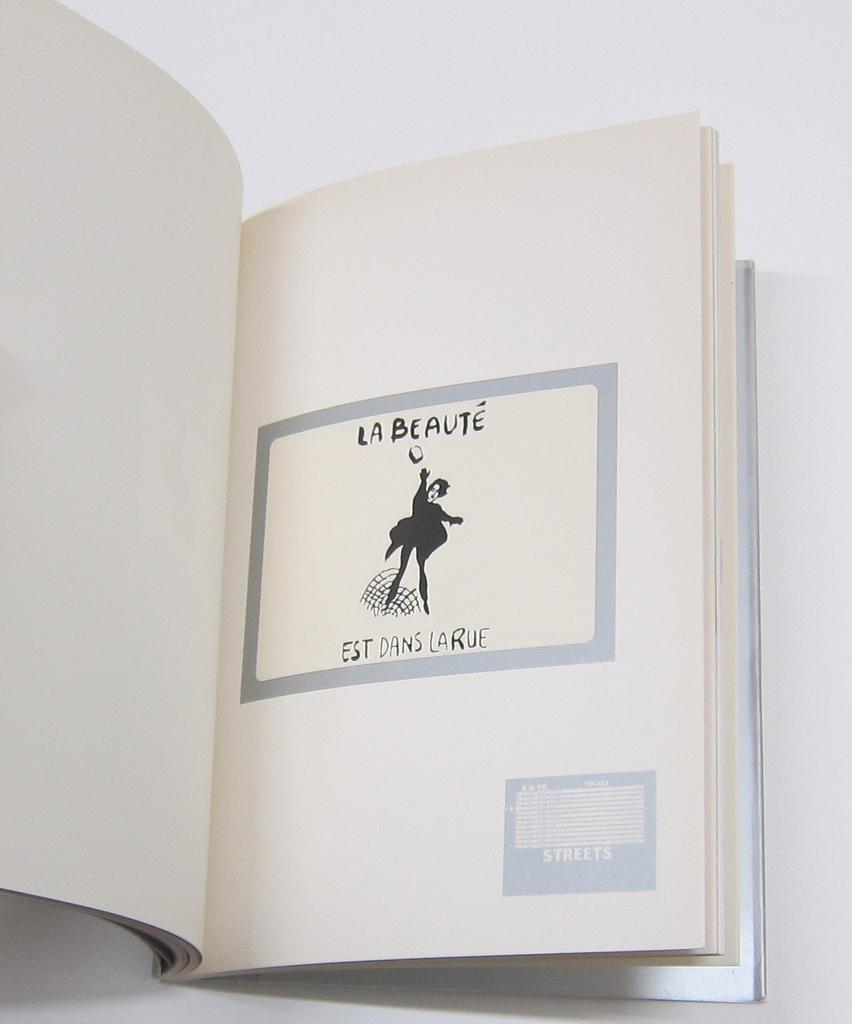What is the name of the book?
Your response must be concise. La beaute. Is la beaute' the name of this book?
Offer a terse response. Yes. 